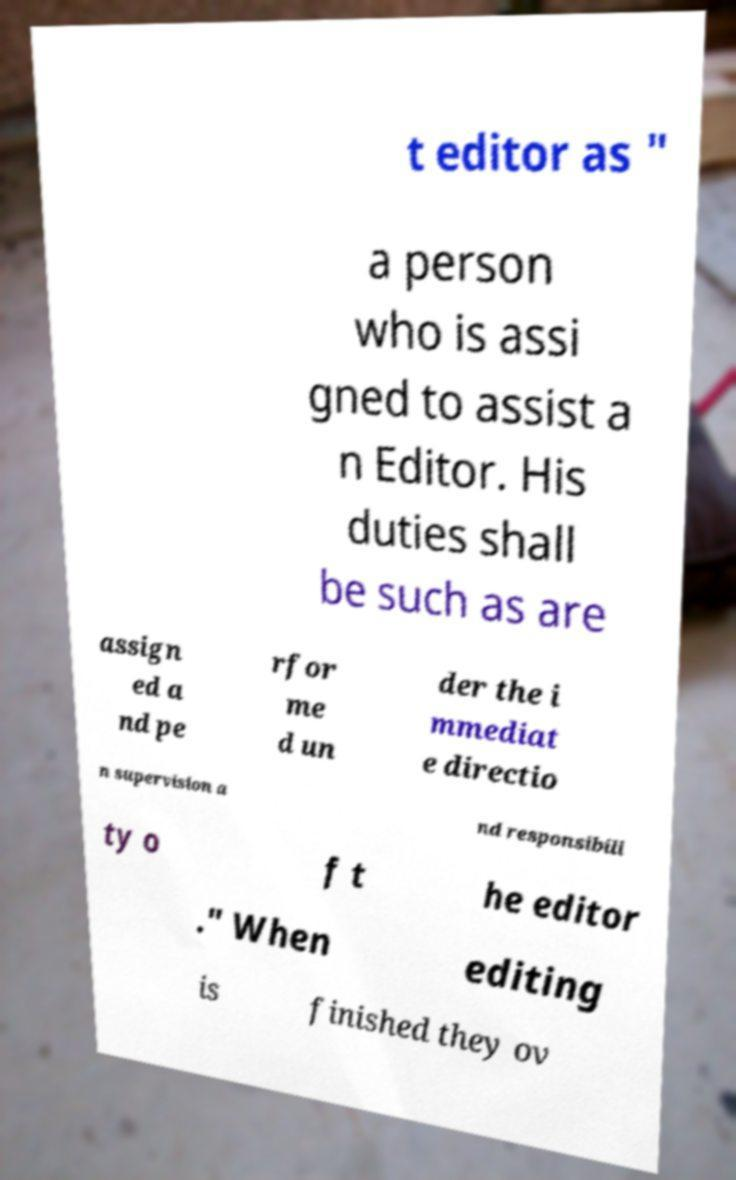Could you assist in decoding the text presented in this image and type it out clearly? t editor as " a person who is assi gned to assist a n Editor. His duties shall be such as are assign ed a nd pe rfor me d un der the i mmediat e directio n supervision a nd responsibili ty o f t he editor ." When editing is finished they ov 